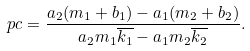<formula> <loc_0><loc_0><loc_500><loc_500>p c = \frac { a _ { 2 } ( m _ { 1 } + b _ { 1 } ) - a _ { 1 } ( m _ { 2 } + b _ { 2 } ) } { a _ { 2 } m _ { 1 } \overline { k _ { 1 } } - a _ { 1 } m _ { 2 } \overline { k _ { 2 } } } .</formula> 